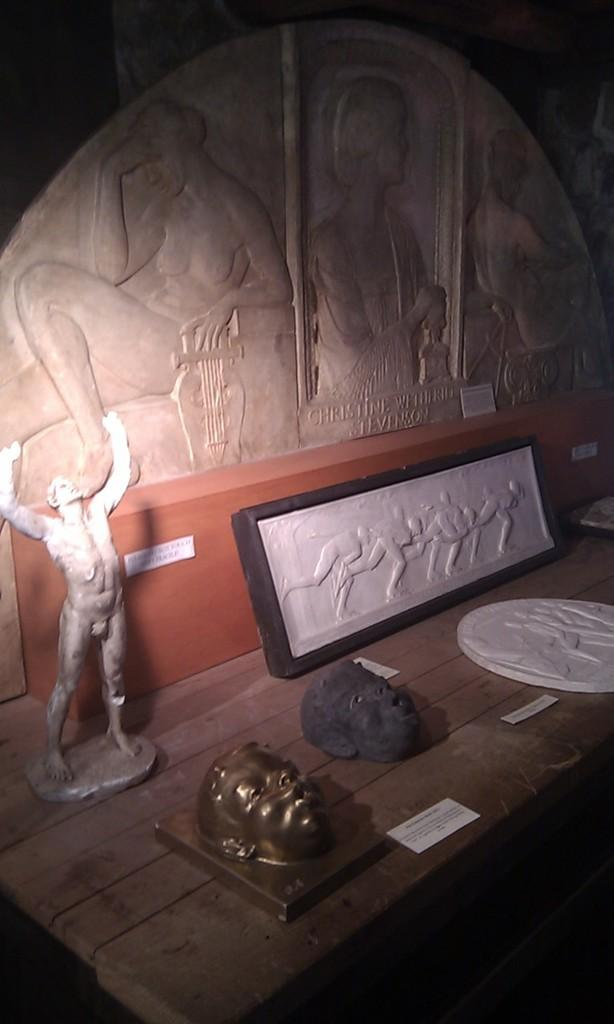What is the main object in the image? There is a table in the image. What is placed on the table? Sculptures are placed on the table. What can be seen in the background of the image? There is a wall in the background of the image. What is featured on the wall? There are carvings on the wall. What type of cherry is being used by the carpenter in the image? There is no carpenter or cherry present in the image. What type of building is depicted in the image? The image does not show a building; it features a table with sculptures and a wall with carvings. 